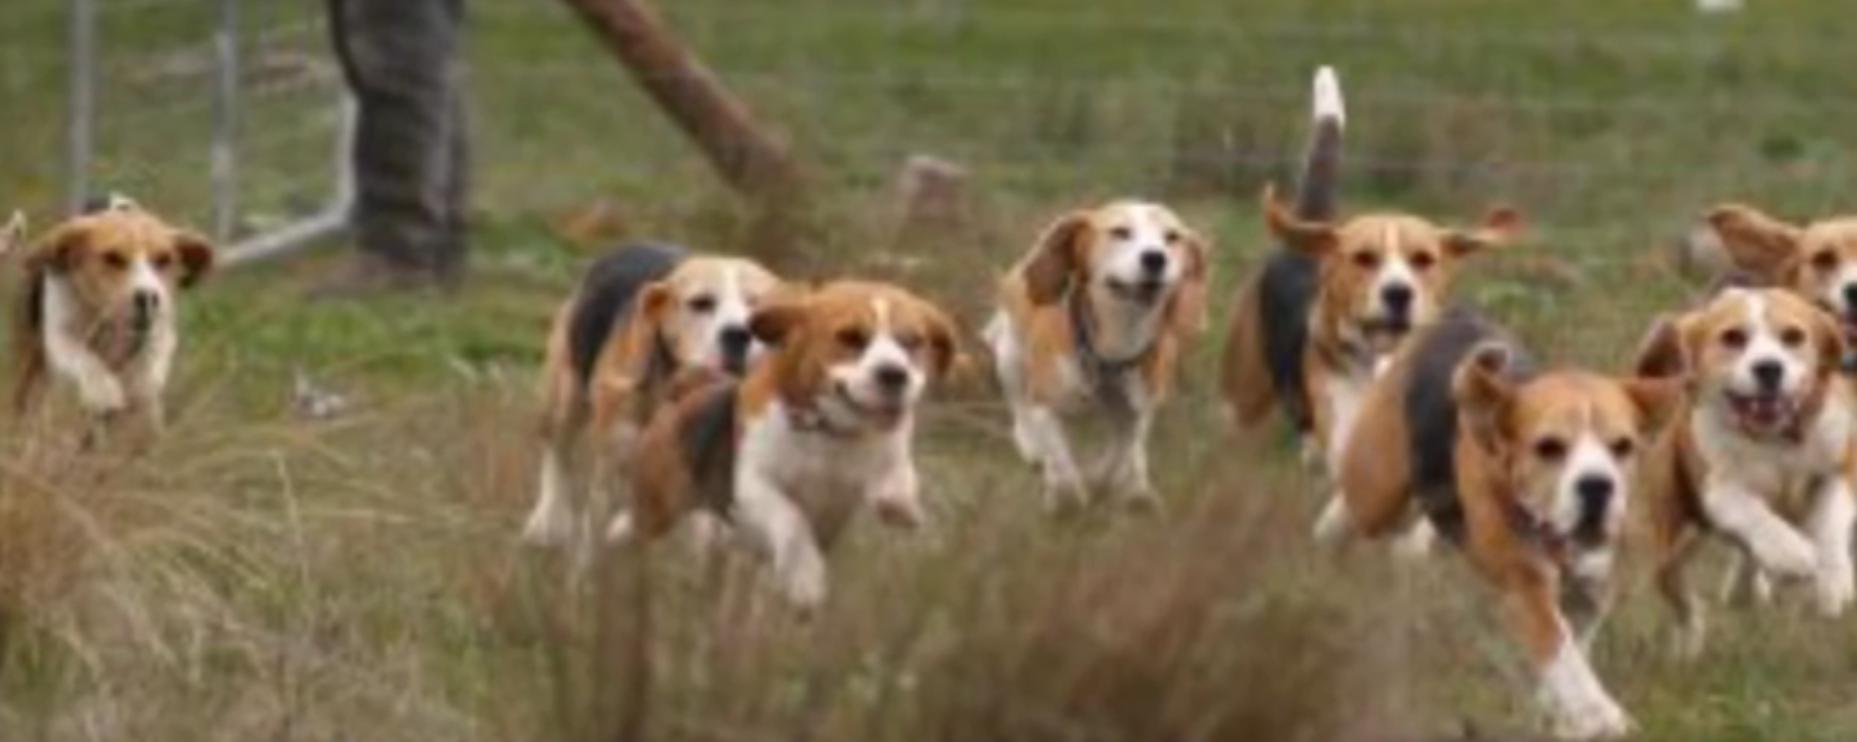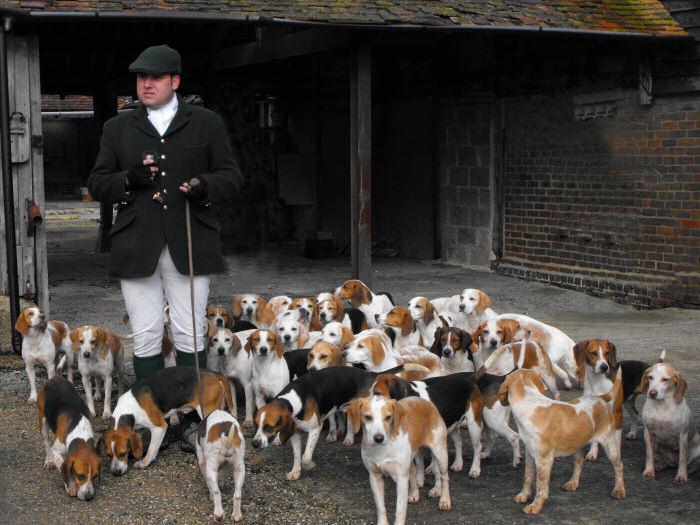The first image is the image on the left, the second image is the image on the right. For the images shown, is this caption "A man is with a group of dogs in a grassy area in the image on the left." true? Answer yes or no. No. 